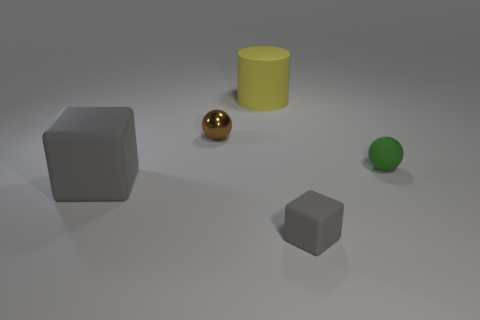Add 2 big yellow metallic balls. How many objects exist? 7 Add 1 green matte objects. How many green matte objects exist? 2 Subtract 0 purple cylinders. How many objects are left? 5 Subtract all cylinders. How many objects are left? 4 Subtract all small balls. Subtract all small brown shiny objects. How many objects are left? 2 Add 2 tiny blocks. How many tiny blocks are left? 3 